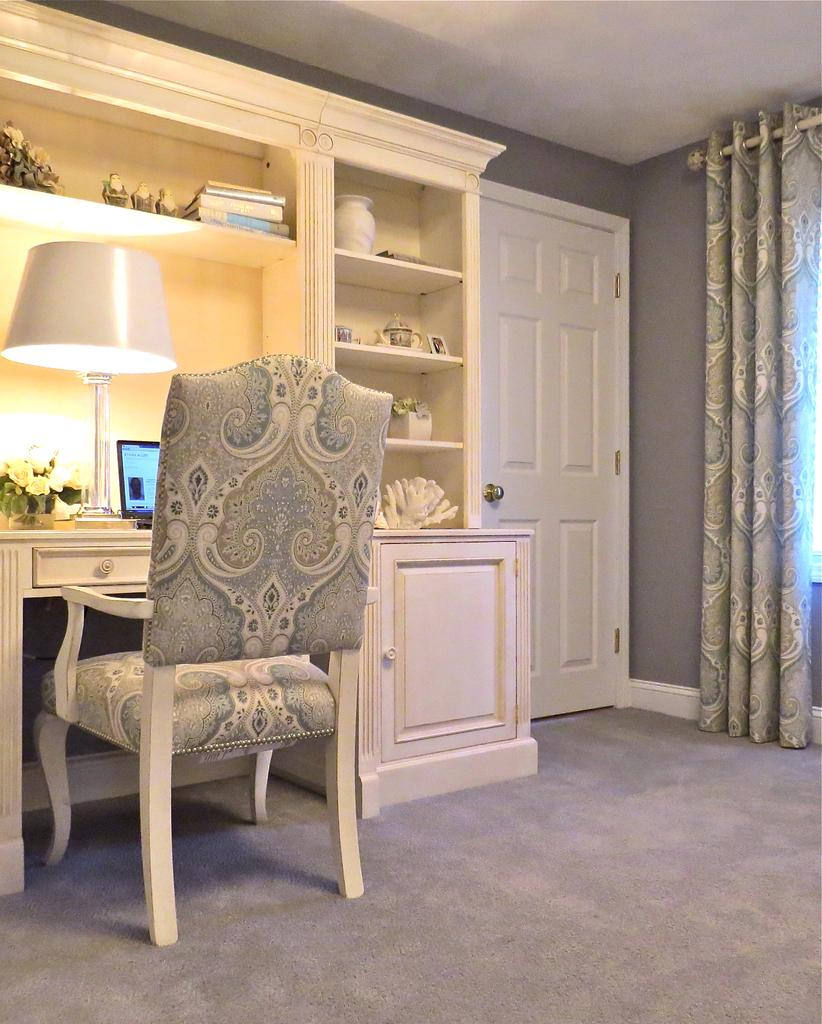What type of furniture is present in the room? There is a chair in the room. What is located in front of the chair? There is a cupboard in front of the chair. What electronic device can be seen in the room? There is a laptop on or near the cupboard. What type of lighting is present in the room? There is a lamp in the room. What type of decoration is present in the room? There are flowers in the room. What is the color of the door on the right side of the room? There is a white door on the right side of the room. What type of window treatment is associated with the white door? There are curtains associated with the white door. What type of net is hanging from the ceiling in the room? There is no net hanging from the ceiling in the room. What type of muscle is visible on the chair in the room? There are no muscles visible on the chair in the room. 